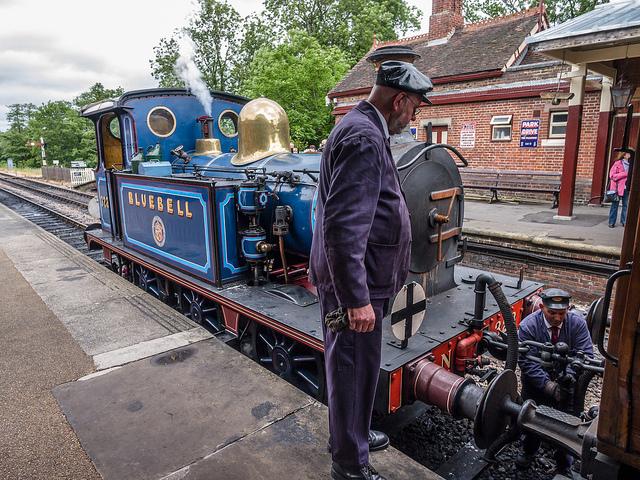Is this a train?
Write a very short answer. Yes. Is the woman wearing a pink jacket?
Be succinct. Yes. What is this train powered by?
Answer briefly. Steam. How many men are there?
Answer briefly. 2. 